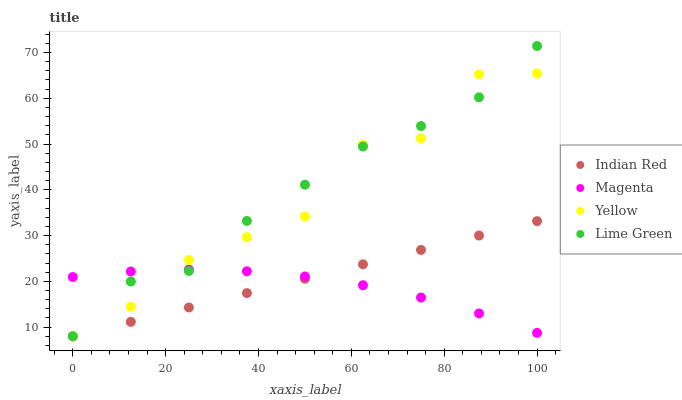Does Magenta have the minimum area under the curve?
Answer yes or no. Yes. Does Lime Green have the maximum area under the curve?
Answer yes or no. Yes. Does Yellow have the minimum area under the curve?
Answer yes or no. No. Does Yellow have the maximum area under the curve?
Answer yes or no. No. Is Indian Red the smoothest?
Answer yes or no. Yes. Is Yellow the roughest?
Answer yes or no. Yes. Is Lime Green the smoothest?
Answer yes or no. No. Is Lime Green the roughest?
Answer yes or no. No. Does Lime Green have the lowest value?
Answer yes or no. Yes. Does Lime Green have the highest value?
Answer yes or no. Yes. Does Yellow have the highest value?
Answer yes or no. No. Does Indian Red intersect Yellow?
Answer yes or no. Yes. Is Indian Red less than Yellow?
Answer yes or no. No. Is Indian Red greater than Yellow?
Answer yes or no. No. 